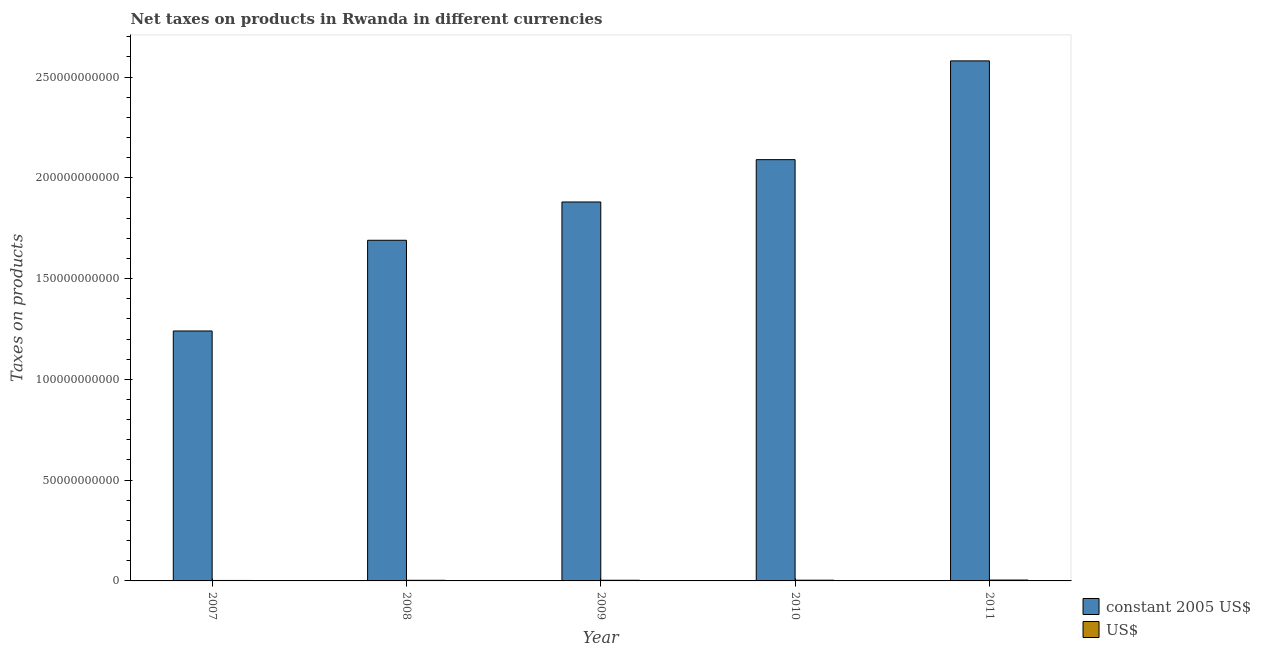How many different coloured bars are there?
Your answer should be compact. 2. How many groups of bars are there?
Give a very brief answer. 5. Are the number of bars per tick equal to the number of legend labels?
Your answer should be very brief. Yes. Are the number of bars on each tick of the X-axis equal?
Your answer should be compact. Yes. How many bars are there on the 1st tick from the left?
Your response must be concise. 2. How many bars are there on the 5th tick from the right?
Your answer should be very brief. 2. In how many cases, is the number of bars for a given year not equal to the number of legend labels?
Provide a succinct answer. 0. What is the net taxes in us$ in 2011?
Provide a short and direct response. 4.30e+08. Across all years, what is the maximum net taxes in constant 2005 us$?
Provide a short and direct response. 2.58e+11. Across all years, what is the minimum net taxes in constant 2005 us$?
Offer a very short reply. 1.24e+11. In which year was the net taxes in constant 2005 us$ maximum?
Give a very brief answer. 2011. In which year was the net taxes in us$ minimum?
Ensure brevity in your answer.  2007. What is the total net taxes in us$ in the graph?
Provide a short and direct response. 1.65e+09. What is the difference between the net taxes in constant 2005 us$ in 2008 and that in 2010?
Ensure brevity in your answer.  -4.00e+1. What is the difference between the net taxes in constant 2005 us$ in 2011 and the net taxes in us$ in 2010?
Ensure brevity in your answer.  4.90e+1. What is the average net taxes in us$ per year?
Keep it short and to the point. 3.31e+08. In the year 2011, what is the difference between the net taxes in us$ and net taxes in constant 2005 us$?
Keep it short and to the point. 0. What is the ratio of the net taxes in constant 2005 us$ in 2008 to that in 2011?
Keep it short and to the point. 0.66. Is the net taxes in constant 2005 us$ in 2008 less than that in 2009?
Offer a terse response. Yes. Is the difference between the net taxes in constant 2005 us$ in 2008 and 2010 greater than the difference between the net taxes in us$ in 2008 and 2010?
Offer a terse response. No. What is the difference between the highest and the second highest net taxes in us$?
Provide a succinct answer. 7.14e+07. What is the difference between the highest and the lowest net taxes in us$?
Offer a terse response. 2.03e+08. Is the sum of the net taxes in us$ in 2009 and 2011 greater than the maximum net taxes in constant 2005 us$ across all years?
Ensure brevity in your answer.  Yes. What does the 1st bar from the left in 2011 represents?
Keep it short and to the point. Constant 2005 us$. What does the 1st bar from the right in 2011 represents?
Make the answer very short. US$. Does the graph contain any zero values?
Provide a succinct answer. No. Where does the legend appear in the graph?
Provide a succinct answer. Bottom right. How many legend labels are there?
Your response must be concise. 2. What is the title of the graph?
Offer a very short reply. Net taxes on products in Rwanda in different currencies. What is the label or title of the X-axis?
Your answer should be compact. Year. What is the label or title of the Y-axis?
Offer a very short reply. Taxes on products. What is the Taxes on products in constant 2005 US$ in 2007?
Provide a short and direct response. 1.24e+11. What is the Taxes on products of US$ in 2007?
Keep it short and to the point. 2.27e+08. What is the Taxes on products in constant 2005 US$ in 2008?
Offer a very short reply. 1.69e+11. What is the Taxes on products of US$ in 2008?
Your answer should be compact. 3.09e+08. What is the Taxes on products of constant 2005 US$ in 2009?
Provide a succinct answer. 1.88e+11. What is the Taxes on products of US$ in 2009?
Give a very brief answer. 3.31e+08. What is the Taxes on products of constant 2005 US$ in 2010?
Make the answer very short. 2.09e+11. What is the Taxes on products of US$ in 2010?
Offer a very short reply. 3.58e+08. What is the Taxes on products in constant 2005 US$ in 2011?
Your answer should be compact. 2.58e+11. What is the Taxes on products in US$ in 2011?
Provide a succinct answer. 4.30e+08. Across all years, what is the maximum Taxes on products in constant 2005 US$?
Your answer should be very brief. 2.58e+11. Across all years, what is the maximum Taxes on products of US$?
Your answer should be very brief. 4.30e+08. Across all years, what is the minimum Taxes on products in constant 2005 US$?
Your answer should be compact. 1.24e+11. Across all years, what is the minimum Taxes on products of US$?
Ensure brevity in your answer.  2.27e+08. What is the total Taxes on products of constant 2005 US$ in the graph?
Provide a short and direct response. 9.48e+11. What is the total Taxes on products in US$ in the graph?
Give a very brief answer. 1.65e+09. What is the difference between the Taxes on products in constant 2005 US$ in 2007 and that in 2008?
Give a very brief answer. -4.50e+1. What is the difference between the Taxes on products in US$ in 2007 and that in 2008?
Make the answer very short. -8.23e+07. What is the difference between the Taxes on products of constant 2005 US$ in 2007 and that in 2009?
Provide a short and direct response. -6.40e+1. What is the difference between the Taxes on products in US$ in 2007 and that in 2009?
Your answer should be very brief. -1.04e+08. What is the difference between the Taxes on products of constant 2005 US$ in 2007 and that in 2010?
Give a very brief answer. -8.50e+1. What is the difference between the Taxes on products in US$ in 2007 and that in 2010?
Keep it short and to the point. -1.32e+08. What is the difference between the Taxes on products in constant 2005 US$ in 2007 and that in 2011?
Your response must be concise. -1.34e+11. What is the difference between the Taxes on products in US$ in 2007 and that in 2011?
Offer a very short reply. -2.03e+08. What is the difference between the Taxes on products of constant 2005 US$ in 2008 and that in 2009?
Give a very brief answer. -1.90e+1. What is the difference between the Taxes on products of US$ in 2008 and that in 2009?
Give a very brief answer. -2.18e+07. What is the difference between the Taxes on products in constant 2005 US$ in 2008 and that in 2010?
Give a very brief answer. -4.00e+1. What is the difference between the Taxes on products in US$ in 2008 and that in 2010?
Your answer should be very brief. -4.94e+07. What is the difference between the Taxes on products in constant 2005 US$ in 2008 and that in 2011?
Keep it short and to the point. -8.90e+1. What is the difference between the Taxes on products of US$ in 2008 and that in 2011?
Give a very brief answer. -1.21e+08. What is the difference between the Taxes on products of constant 2005 US$ in 2009 and that in 2010?
Ensure brevity in your answer.  -2.10e+1. What is the difference between the Taxes on products in US$ in 2009 and that in 2010?
Ensure brevity in your answer.  -2.76e+07. What is the difference between the Taxes on products of constant 2005 US$ in 2009 and that in 2011?
Make the answer very short. -7.00e+1. What is the difference between the Taxes on products in US$ in 2009 and that in 2011?
Your answer should be very brief. -9.90e+07. What is the difference between the Taxes on products of constant 2005 US$ in 2010 and that in 2011?
Keep it short and to the point. -4.90e+1. What is the difference between the Taxes on products in US$ in 2010 and that in 2011?
Provide a short and direct response. -7.14e+07. What is the difference between the Taxes on products of constant 2005 US$ in 2007 and the Taxes on products of US$ in 2008?
Keep it short and to the point. 1.24e+11. What is the difference between the Taxes on products in constant 2005 US$ in 2007 and the Taxes on products in US$ in 2009?
Provide a succinct answer. 1.24e+11. What is the difference between the Taxes on products of constant 2005 US$ in 2007 and the Taxes on products of US$ in 2010?
Offer a terse response. 1.24e+11. What is the difference between the Taxes on products in constant 2005 US$ in 2007 and the Taxes on products in US$ in 2011?
Keep it short and to the point. 1.24e+11. What is the difference between the Taxes on products in constant 2005 US$ in 2008 and the Taxes on products in US$ in 2009?
Your response must be concise. 1.69e+11. What is the difference between the Taxes on products in constant 2005 US$ in 2008 and the Taxes on products in US$ in 2010?
Make the answer very short. 1.69e+11. What is the difference between the Taxes on products in constant 2005 US$ in 2008 and the Taxes on products in US$ in 2011?
Your response must be concise. 1.69e+11. What is the difference between the Taxes on products of constant 2005 US$ in 2009 and the Taxes on products of US$ in 2010?
Provide a succinct answer. 1.88e+11. What is the difference between the Taxes on products in constant 2005 US$ in 2009 and the Taxes on products in US$ in 2011?
Your answer should be very brief. 1.88e+11. What is the difference between the Taxes on products of constant 2005 US$ in 2010 and the Taxes on products of US$ in 2011?
Provide a short and direct response. 2.09e+11. What is the average Taxes on products in constant 2005 US$ per year?
Provide a succinct answer. 1.90e+11. What is the average Taxes on products of US$ per year?
Provide a short and direct response. 3.31e+08. In the year 2007, what is the difference between the Taxes on products in constant 2005 US$ and Taxes on products in US$?
Offer a very short reply. 1.24e+11. In the year 2008, what is the difference between the Taxes on products of constant 2005 US$ and Taxes on products of US$?
Make the answer very short. 1.69e+11. In the year 2009, what is the difference between the Taxes on products of constant 2005 US$ and Taxes on products of US$?
Give a very brief answer. 1.88e+11. In the year 2010, what is the difference between the Taxes on products in constant 2005 US$ and Taxes on products in US$?
Your response must be concise. 2.09e+11. In the year 2011, what is the difference between the Taxes on products of constant 2005 US$ and Taxes on products of US$?
Provide a succinct answer. 2.58e+11. What is the ratio of the Taxes on products of constant 2005 US$ in 2007 to that in 2008?
Your answer should be very brief. 0.73. What is the ratio of the Taxes on products in US$ in 2007 to that in 2008?
Your answer should be compact. 0.73. What is the ratio of the Taxes on products of constant 2005 US$ in 2007 to that in 2009?
Offer a terse response. 0.66. What is the ratio of the Taxes on products of US$ in 2007 to that in 2009?
Provide a short and direct response. 0.69. What is the ratio of the Taxes on products in constant 2005 US$ in 2007 to that in 2010?
Provide a succinct answer. 0.59. What is the ratio of the Taxes on products in US$ in 2007 to that in 2010?
Your answer should be very brief. 0.63. What is the ratio of the Taxes on products in constant 2005 US$ in 2007 to that in 2011?
Provide a short and direct response. 0.48. What is the ratio of the Taxes on products in US$ in 2007 to that in 2011?
Give a very brief answer. 0.53. What is the ratio of the Taxes on products of constant 2005 US$ in 2008 to that in 2009?
Give a very brief answer. 0.9. What is the ratio of the Taxes on products of US$ in 2008 to that in 2009?
Give a very brief answer. 0.93. What is the ratio of the Taxes on products in constant 2005 US$ in 2008 to that in 2010?
Your answer should be very brief. 0.81. What is the ratio of the Taxes on products of US$ in 2008 to that in 2010?
Your answer should be compact. 0.86. What is the ratio of the Taxes on products in constant 2005 US$ in 2008 to that in 2011?
Your answer should be very brief. 0.66. What is the ratio of the Taxes on products in US$ in 2008 to that in 2011?
Make the answer very short. 0.72. What is the ratio of the Taxes on products of constant 2005 US$ in 2009 to that in 2010?
Your answer should be compact. 0.9. What is the ratio of the Taxes on products in US$ in 2009 to that in 2010?
Make the answer very short. 0.92. What is the ratio of the Taxes on products in constant 2005 US$ in 2009 to that in 2011?
Your answer should be very brief. 0.73. What is the ratio of the Taxes on products of US$ in 2009 to that in 2011?
Your answer should be compact. 0.77. What is the ratio of the Taxes on products in constant 2005 US$ in 2010 to that in 2011?
Offer a terse response. 0.81. What is the ratio of the Taxes on products in US$ in 2010 to that in 2011?
Your answer should be compact. 0.83. What is the difference between the highest and the second highest Taxes on products in constant 2005 US$?
Provide a short and direct response. 4.90e+1. What is the difference between the highest and the second highest Taxes on products in US$?
Your answer should be compact. 7.14e+07. What is the difference between the highest and the lowest Taxes on products of constant 2005 US$?
Ensure brevity in your answer.  1.34e+11. What is the difference between the highest and the lowest Taxes on products in US$?
Offer a terse response. 2.03e+08. 